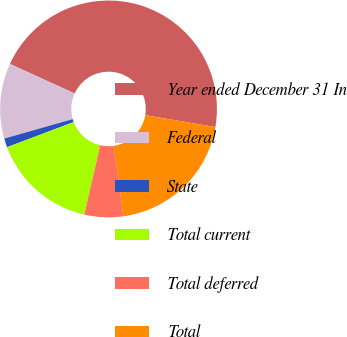Convert chart to OTSL. <chart><loc_0><loc_0><loc_500><loc_500><pie_chart><fcel>Year ended December 31 In<fcel>Federal<fcel>State<fcel>Total current<fcel>Total deferred<fcel>Total<nl><fcel>45.87%<fcel>11.22%<fcel>1.33%<fcel>15.68%<fcel>5.78%<fcel>20.13%<nl></chart> 